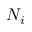<formula> <loc_0><loc_0><loc_500><loc_500>N _ { i }</formula> 